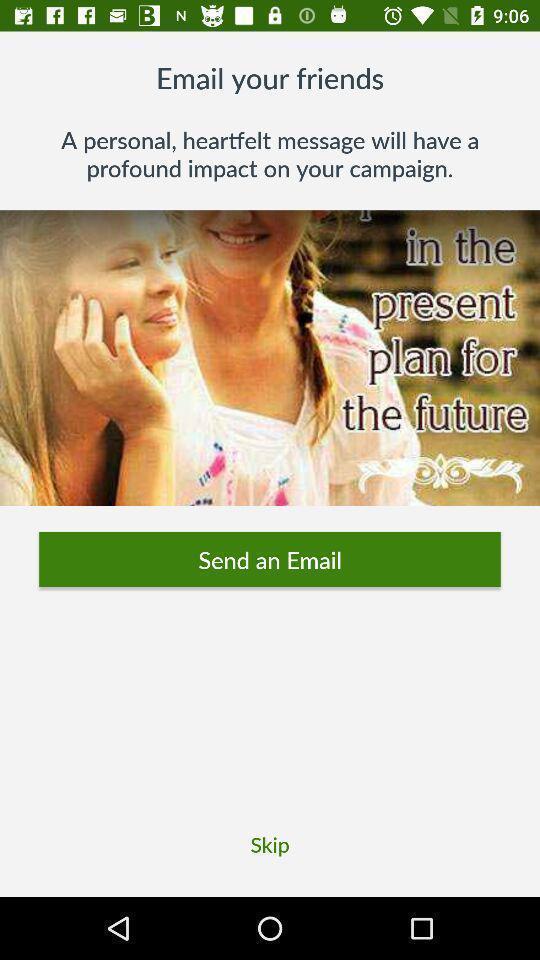Describe the content in this image. Window displaying a fundraising app. 